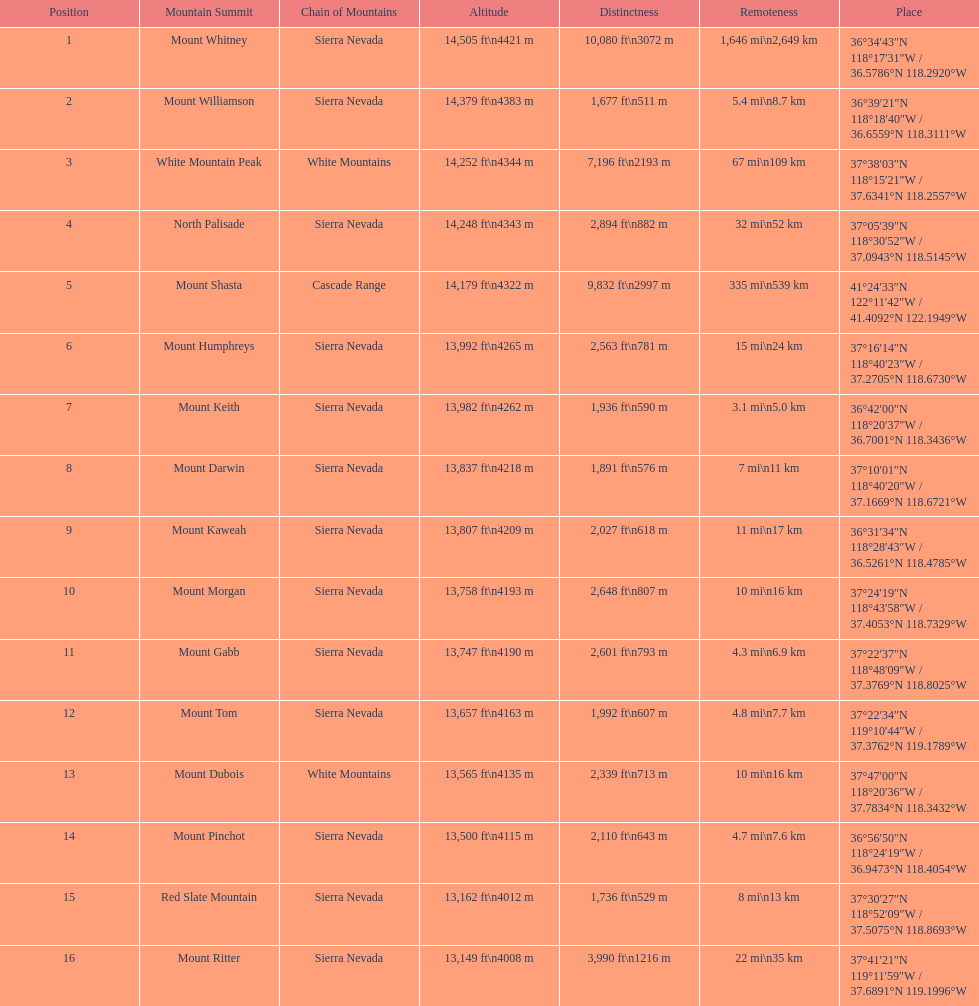What are the listed elevations? 14,505 ft\n4421 m, 14,379 ft\n4383 m, 14,252 ft\n4344 m, 14,248 ft\n4343 m, 14,179 ft\n4322 m, 13,992 ft\n4265 m, 13,982 ft\n4262 m, 13,837 ft\n4218 m, 13,807 ft\n4209 m, 13,758 ft\n4193 m, 13,747 ft\n4190 m, 13,657 ft\n4163 m, 13,565 ft\n4135 m, 13,500 ft\n4115 m, 13,162 ft\n4012 m, 13,149 ft\n4008 m. Which of those is 13,149 ft or below? 13,149 ft\n4008 m. To what mountain peak does that value correspond? Mount Ritter. 